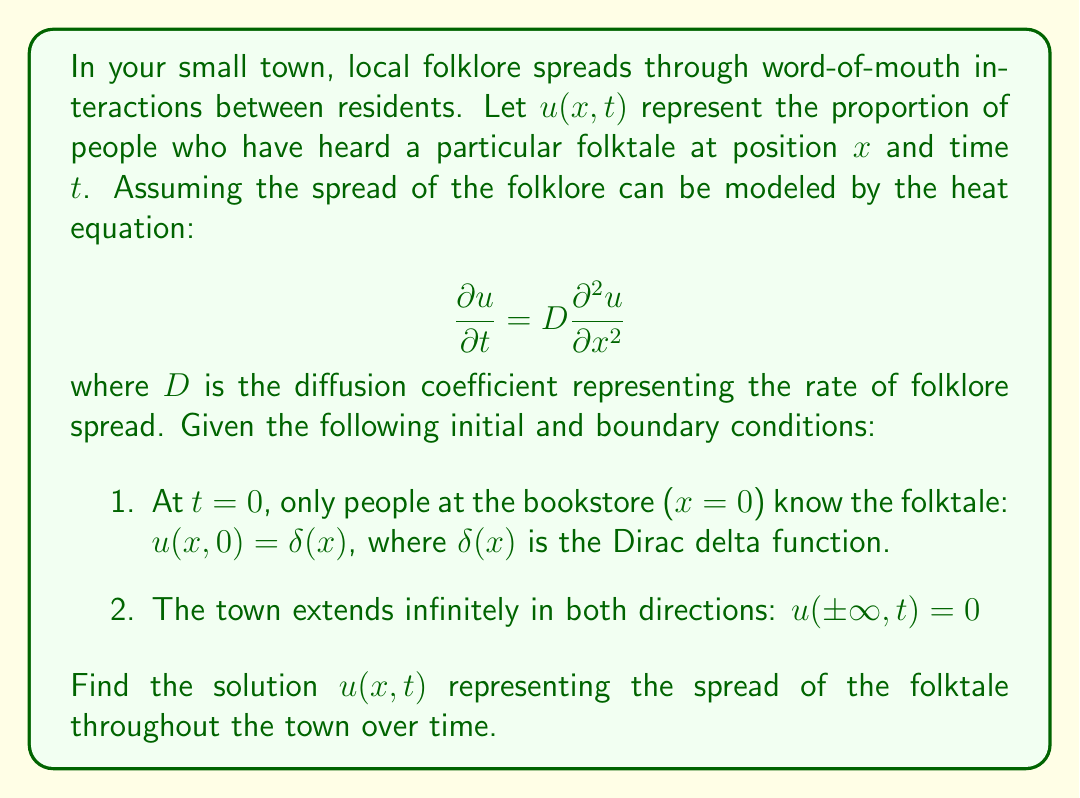Help me with this question. To solve this partial differential equation (PDE), we'll use the following steps:

1) First, we recognize that this is the heat equation with a point source initial condition. The solution to this problem is known as the fundamental solution or Green's function for the heat equation in one dimension.

2) The general form of the solution is:

   $$u(x,t) = \frac{1}{\sqrt{4\pi Dt}} e^{-\frac{x^2}{4Dt}}$$

3) To verify this solution, we can check if it satisfies the PDE and the initial/boundary conditions:

   a) Checking the PDE:
      $$\frac{\partial u}{\partial t} = D\frac{\partial^2 u}{\partial x^2}$$
      
      Left-hand side:
      $$\frac{\partial u}{\partial t} = \frac{\partial}{\partial t}\left(\frac{1}{\sqrt{4\pi Dt}} e^{-\frac{x^2}{4Dt}}\right) = \frac{x^2}{8\sqrt{\pi}D^{3/2}t^{5/2}}e^{-\frac{x^2}{4Dt}} - \frac{1}{2\sqrt{4\pi D}t^{3/2}}e^{-\frac{x^2}{4Dt}}$$
      
      Right-hand side:
      $$D\frac{\partial^2 u}{\partial x^2} = D\frac{\partial^2}{\partial x^2}\left(\frac{1}{\sqrt{4\pi Dt}} e^{-\frac{x^2}{4Dt}}\right) = \frac{x^2}{8\sqrt{\pi}D^{3/2}t^{5/2}}e^{-\frac{x^2}{4Dt}} - \frac{1}{2\sqrt{4\pi D}t^{3/2}}e^{-\frac{x^2}{4Dt}}$$
      
      Both sides are equal, so the PDE is satisfied.

   b) Checking the initial condition:
      As $t \to 0$, $u(x,t)$ approaches the Dirac delta function $\delta(x)$.

   c) Checking the boundary conditions:
      As $x \to \pm\infty$, $e^{-\frac{x^2}{4Dt}} \to 0$, so $u(\pm\infty,t) = 0$.

4) Therefore, the solution satisfies all conditions and is the correct solution to the given PDE problem.
Answer: The solution to the PDE modeling the spread of local folklore through the town over time is:

$$u(x,t) = \frac{1}{\sqrt{4\pi Dt}} e^{-\frac{x^2}{4Dt}}$$

where $u(x,t)$ represents the proportion of people who have heard the folktale at position $x$ and time $t$, and $D$ is the diffusion coefficient representing the rate of folklore spread. 